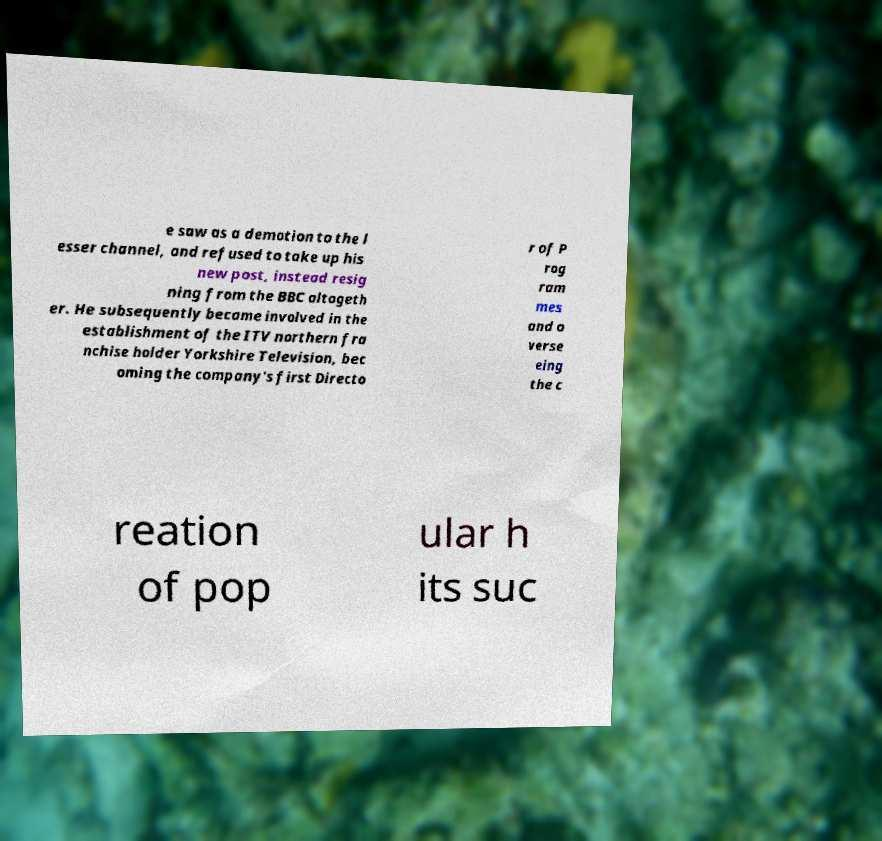Please read and relay the text visible in this image. What does it say? e saw as a demotion to the l esser channel, and refused to take up his new post, instead resig ning from the BBC altogeth er. He subsequently became involved in the establishment of the ITV northern fra nchise holder Yorkshire Television, bec oming the company's first Directo r of P rog ram mes and o verse eing the c reation of pop ular h its suc 